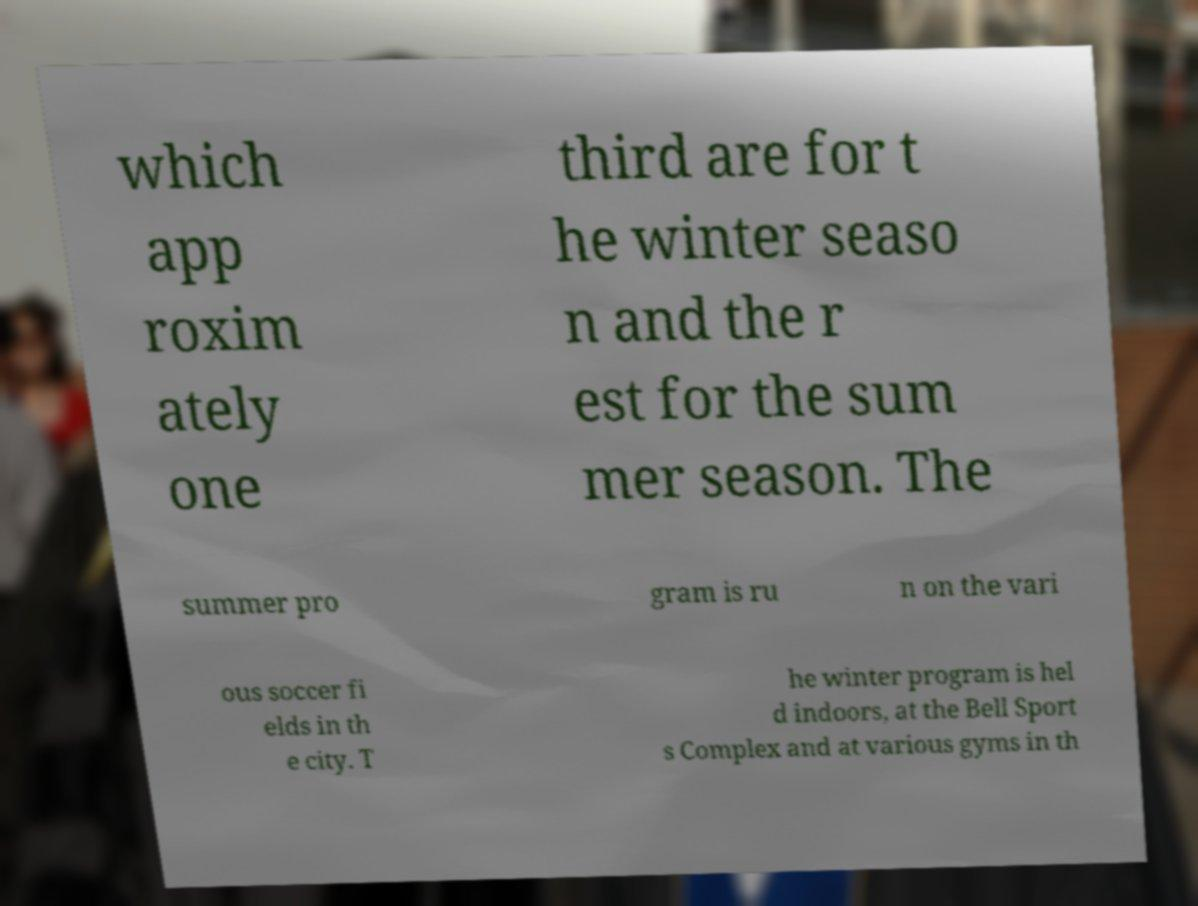Could you assist in decoding the text presented in this image and type it out clearly? which app roxim ately one third are for t he winter seaso n and the r est for the sum mer season. The summer pro gram is ru n on the vari ous soccer fi elds in th e city. T he winter program is hel d indoors, at the Bell Sport s Complex and at various gyms in th 